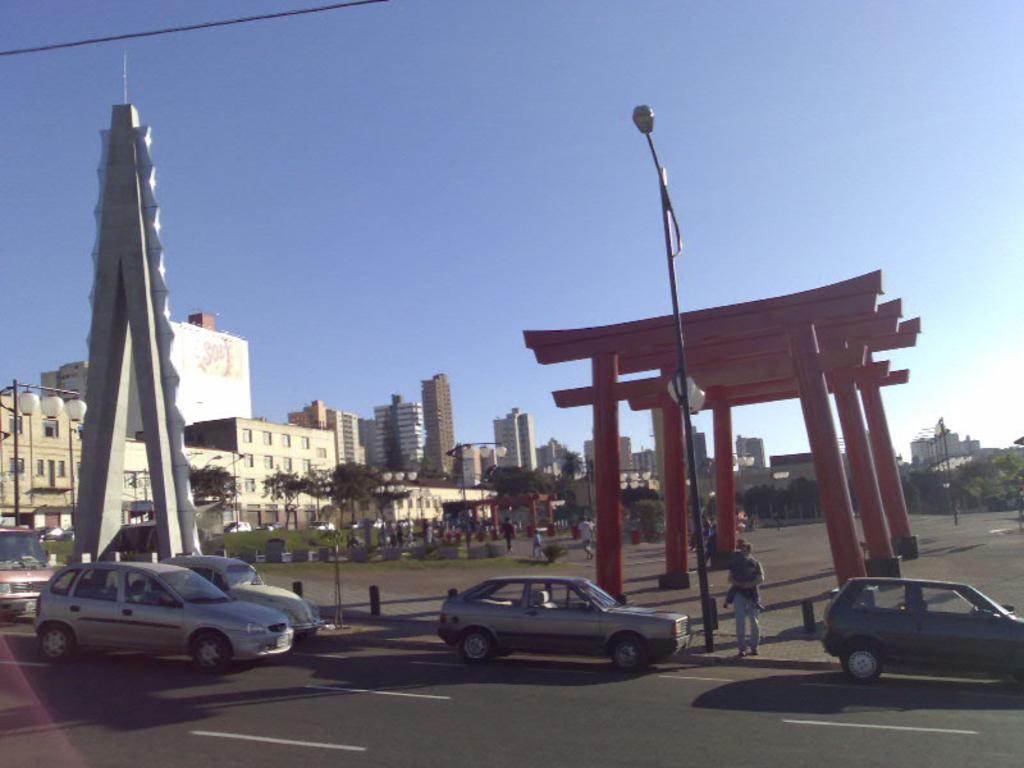What is happening on the right side of the image? There are vehicles moving on the road on the right side of the image. What can be seen on the left side of the image? There are buildings on the left side of the image. What is visible at the top of the image? The sky is visible at the top of the image. What type of verse can be heard in the image? There is no verse or sound present in the image; it is a still image of vehicles and buildings. What rhythm is the shape of the buildings following in the image? There is no mention of a specific shape or rhythm in the image; the buildings are simply depicted as they are. 